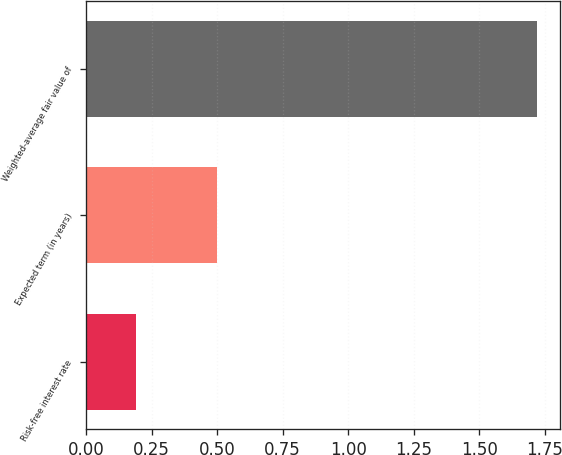Convert chart to OTSL. <chart><loc_0><loc_0><loc_500><loc_500><bar_chart><fcel>Risk-free interest rate<fcel>Expected term (in years)<fcel>Weighted-average fair value of<nl><fcel>0.19<fcel>0.5<fcel>1.72<nl></chart> 